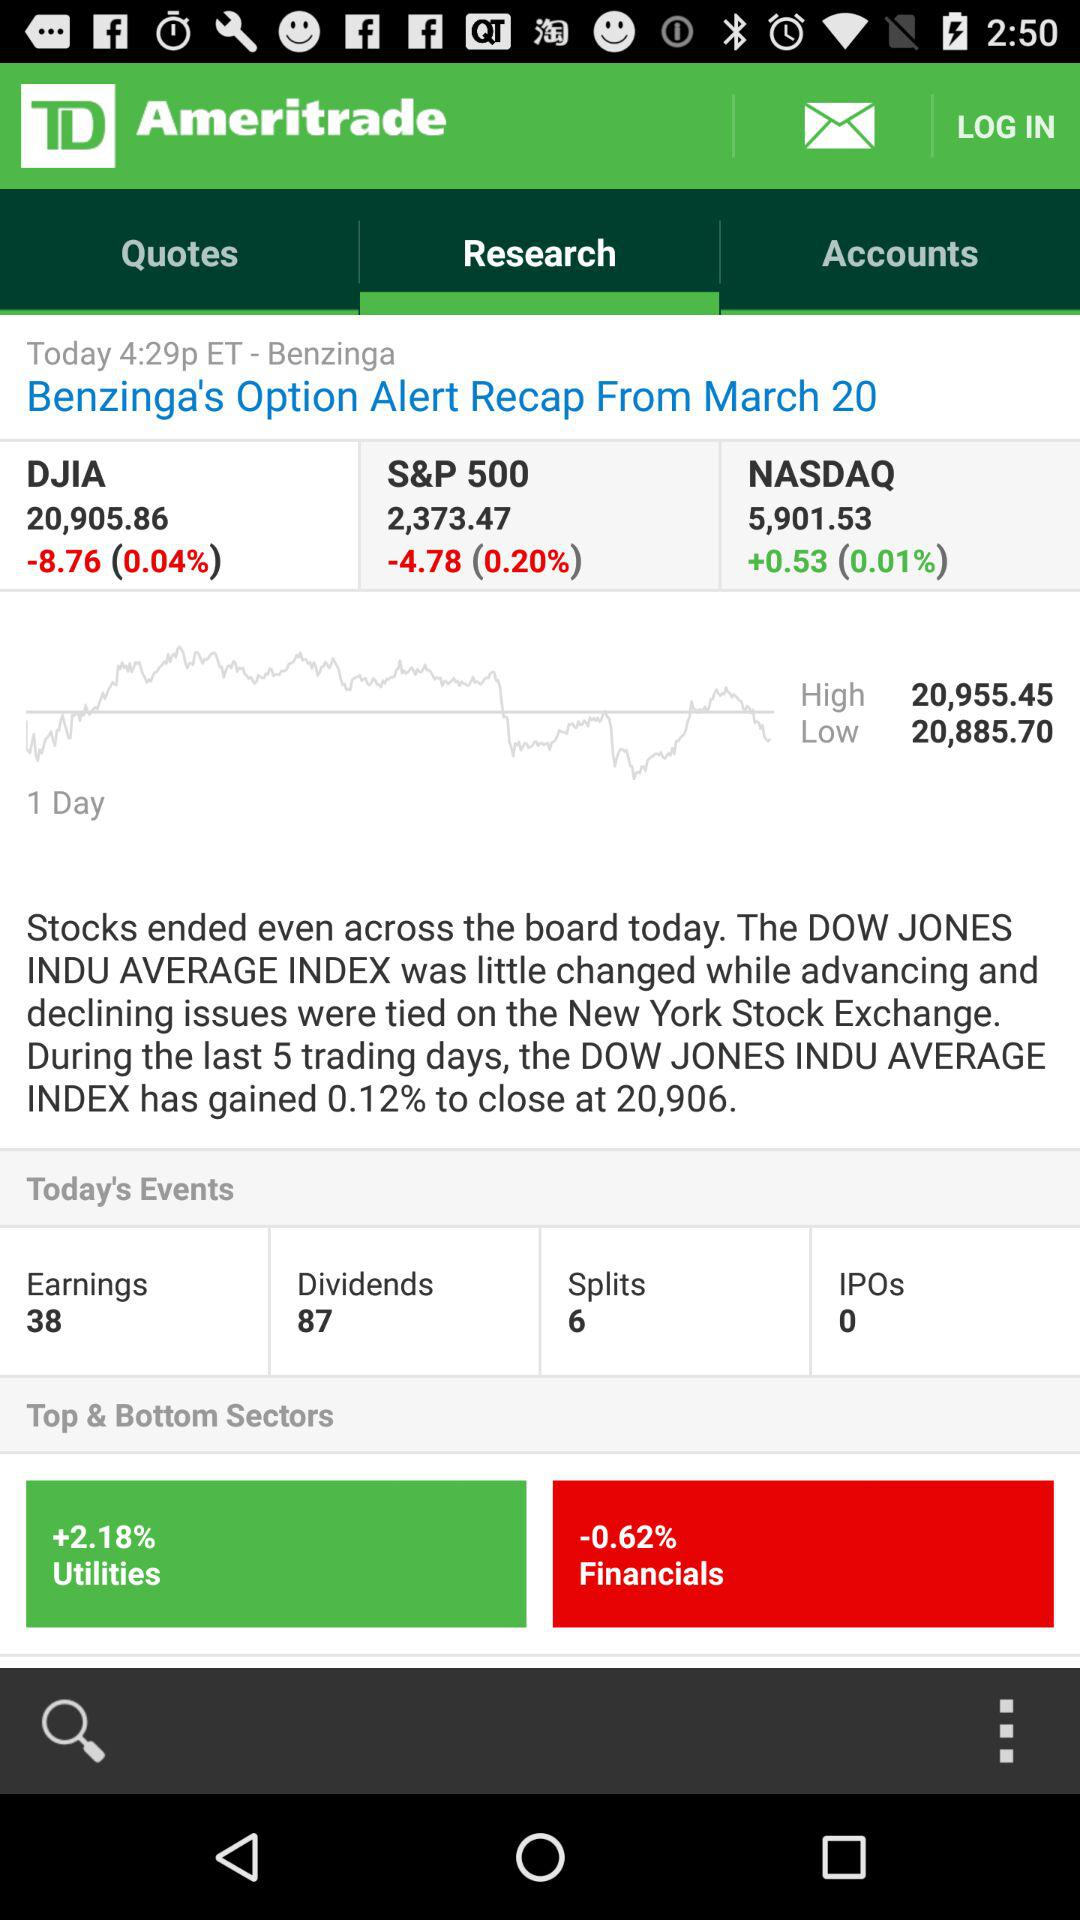What is the date? The date is March 20. 